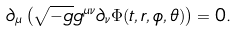<formula> <loc_0><loc_0><loc_500><loc_500>\partial _ { \mu } \left ( \sqrt { - g } g ^ { \mu \nu } \partial _ { \nu } \Phi ( t , r , \phi , \theta ) \right ) = 0 .</formula> 